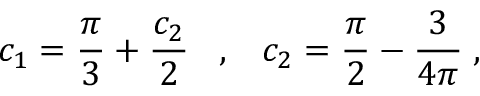<formula> <loc_0><loc_0><loc_500><loc_500>c _ { 1 } = \frac { \pi } { 3 } + \frac { c _ { 2 } } { 2 } \, , \, c _ { 2 } = \frac { \pi } { 2 } - \frac { 3 } { 4 \pi } \, ,</formula> 